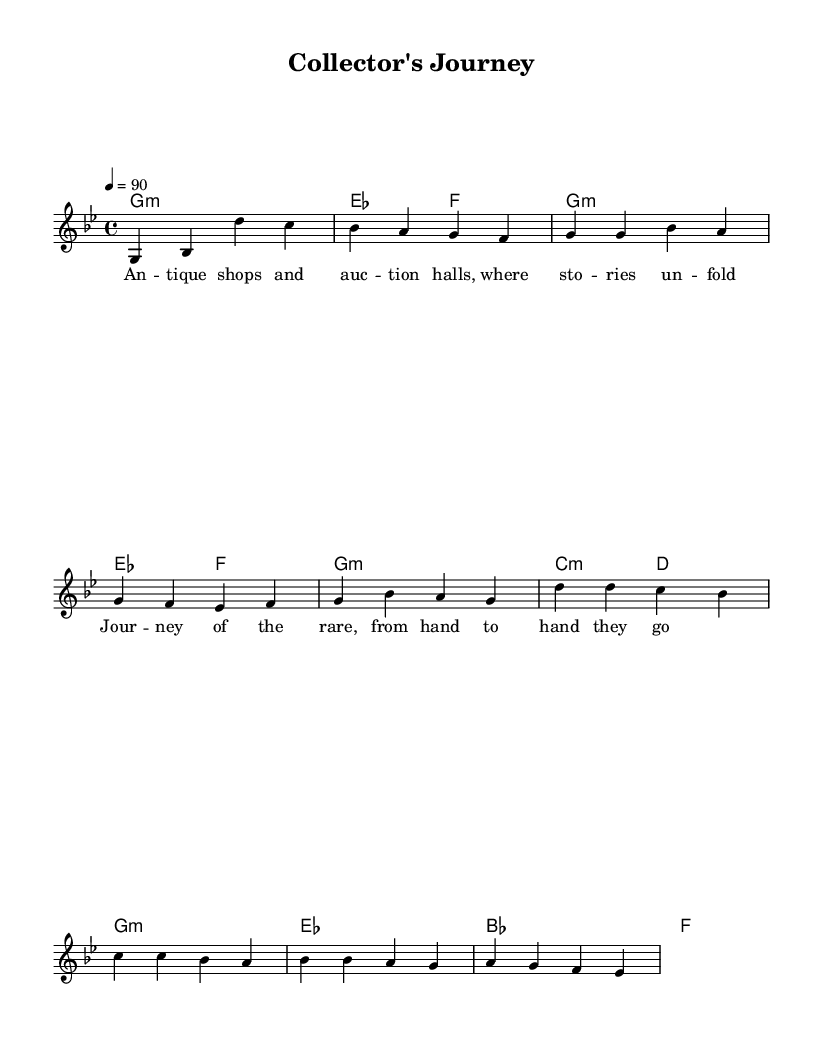What is the key signature of this music? The key signature indicated at the beginning of the music is G minor, which typically has two flats (B flat and E flat) but doesn't show in the actual staff in this case.
Answer: G minor What is the time signature of this music? The time signature is shown at the beginning of the music and is 4/4, meaning there are four beats per measure.
Answer: 4/4 What is the tempo marking for this music? The tempo marked at the beginning indicates that the music should be played at a speed of 90 beats per minute.
Answer: 90 How many verses are in this piece? By analyzing the structure of the lyrics, there is one unique verse followed by a repeated chorus, indicating one verse.
Answer: One What is the main theme of the lyrics? The lyrics highlight the journey and stories behind rare collectibles, expressed through a narrative style typical of hip hop storytelling.
Answer: Journey of rare collectibles What musical section follows the verse? The music transitions from the verse directly to the chorus, which is a common structure in hip hop music where the chorus follows to emphasize the theme after the storytelling.
Answer: Chorus 